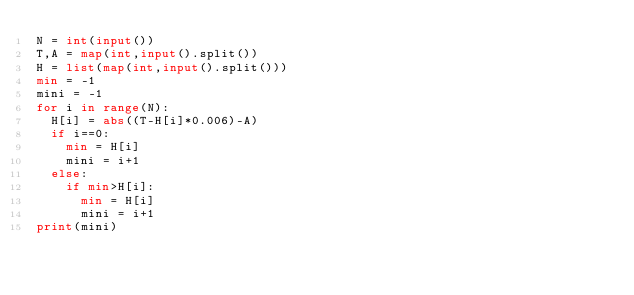<code> <loc_0><loc_0><loc_500><loc_500><_Python_>N = int(input())
T,A = map(int,input().split())
H = list(map(int,input().split()))
min = -1
mini = -1
for i in range(N):
  H[i] = abs((T-H[i]*0.006)-A)
  if i==0:
    min = H[i]
    mini = i+1
  else:
    if min>H[i]:
      min = H[i]
      mini = i+1
print(mini)</code> 